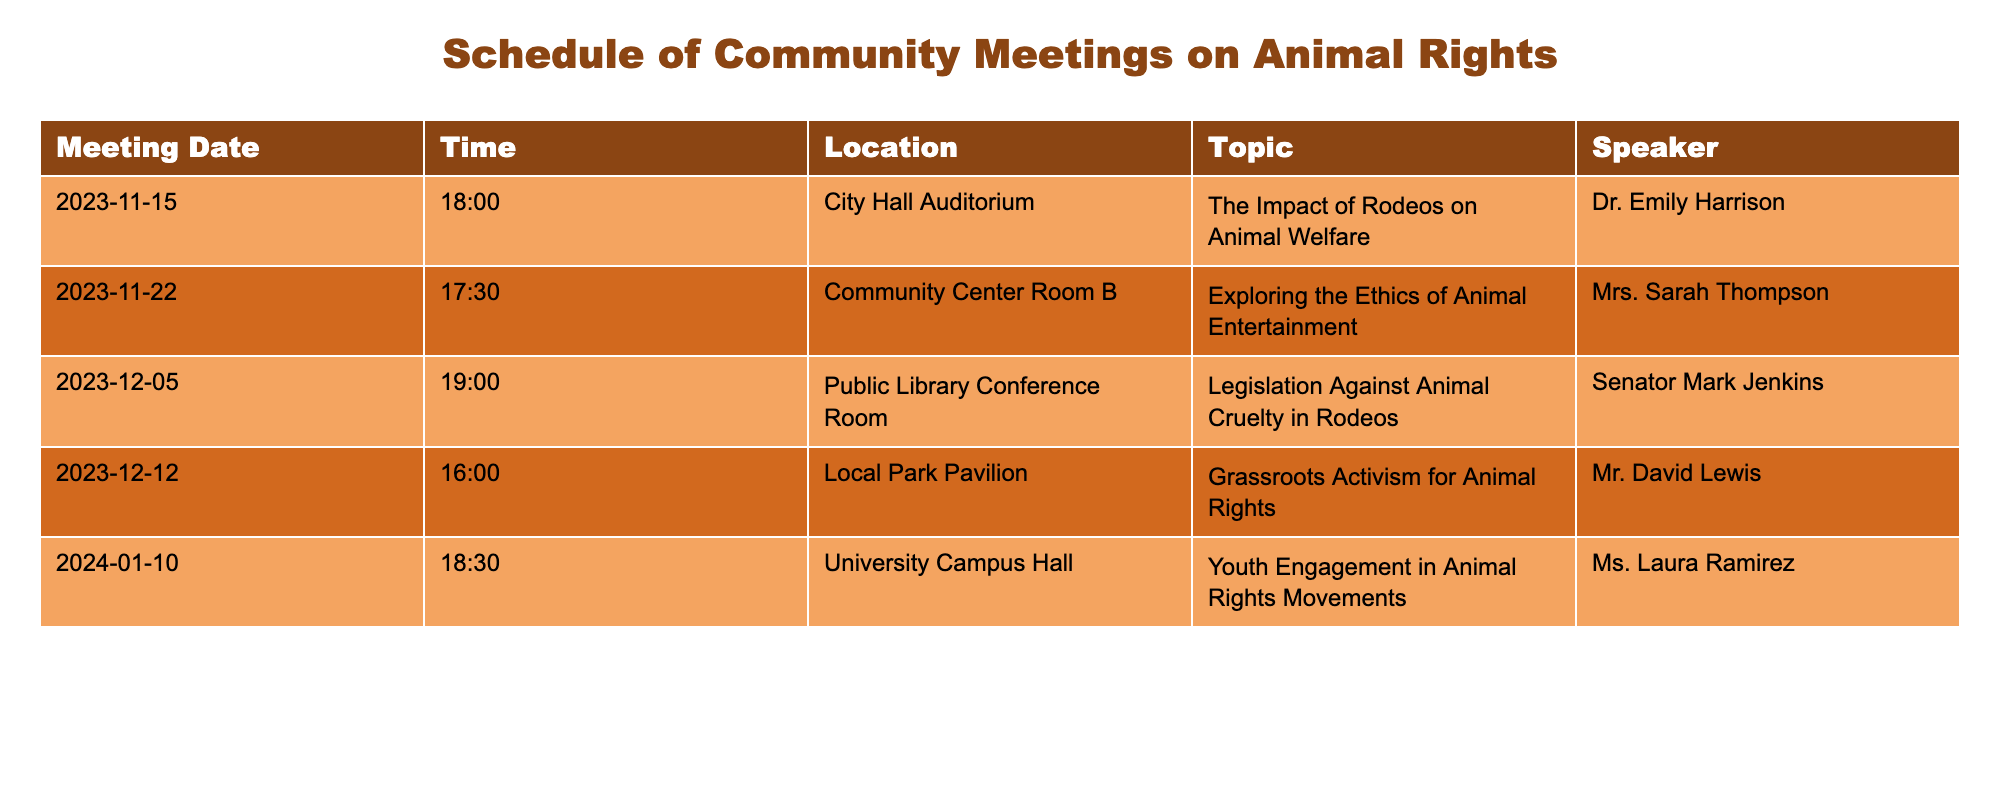What is the date of the meeting focused on the impact of rodeos on animal welfare? The table lists multiple meetings, and the first entry indicates that the meeting on the topic of "The Impact of Rodeos on Animal Welfare" is scheduled for November 15, 2023.
Answer: November 15, 2023 Who is the speaker at the meeting about legislation against animal cruelty in rodeos? Looking at the row for the meeting titled "Legislation Against Animal Cruelty in Rodeos", the speaker is listed as Senator Mark Jenkins.
Answer: Senator Mark Jenkins What time does the meeting on grassroots activism for animal rights start? The table shows that the meeting entitled "Grassroots Activism for Animal Rights" is set to start at 16:00 on December 12, 2023.
Answer: 16:00 Is there a meeting scheduled in December 2023? By reviewing the dates in the table, there are two meetings scheduled in December 2023, specifically on December 5 and December 12. Therefore, the answer is yes.
Answer: Yes How many meetings are scheduled for the year 2024? The table lists a total of five meetings, with one of them, scheduled on January 10, 2024. Therefore, the count for 2024 is one.
Answer: One Which location hosts the meeting focused on exploring the ethics of animal entertainment? Referring to the row for "Exploring the Ethics of Animal Entertainment", it is noted that this meeting will take place in Community Center Room B.
Answer: Community Center Room B What is the average starting time for the meetings listed? To calculate the average starting time, convert all meeting times to minutes after midnight: 18:00 (1080), 17:30 (1050), 19:00 (1140), 16:00 (960), 18:30 (1110). The sum is 5250 minutes, and dividing by 5 gives an average of 1050 minutes, which corresponds to 17:30.
Answer: 17:30 Are any meetings scheduled at City Hall Auditorium? Referring to the rows in the table, it is clear that there is one meeting scheduled at the City Hall Auditorium on November 15, 2023. Hence, the answer is yes.
Answer: Yes What topics are being discussed on the first three meeting dates? The topics are: "The Impact of Rodeos on Animal Welfare" on November 15, "Exploring the Ethics of Animal Entertainment" on November 22, and "Legislation Against Animal Cruelty in Rodeos" on December 5.
Answer: See explanation for topics on specified dates 